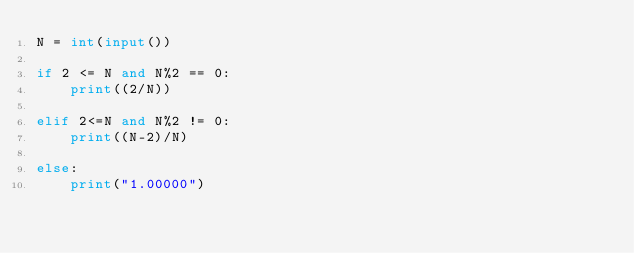Convert code to text. <code><loc_0><loc_0><loc_500><loc_500><_Python_>N = int(input())

if 2 <= N and N%2 == 0:
    print((2/N))

elif 2<=N and N%2 != 0:
    print((N-2)/N)

else:
    print("1.00000")</code> 